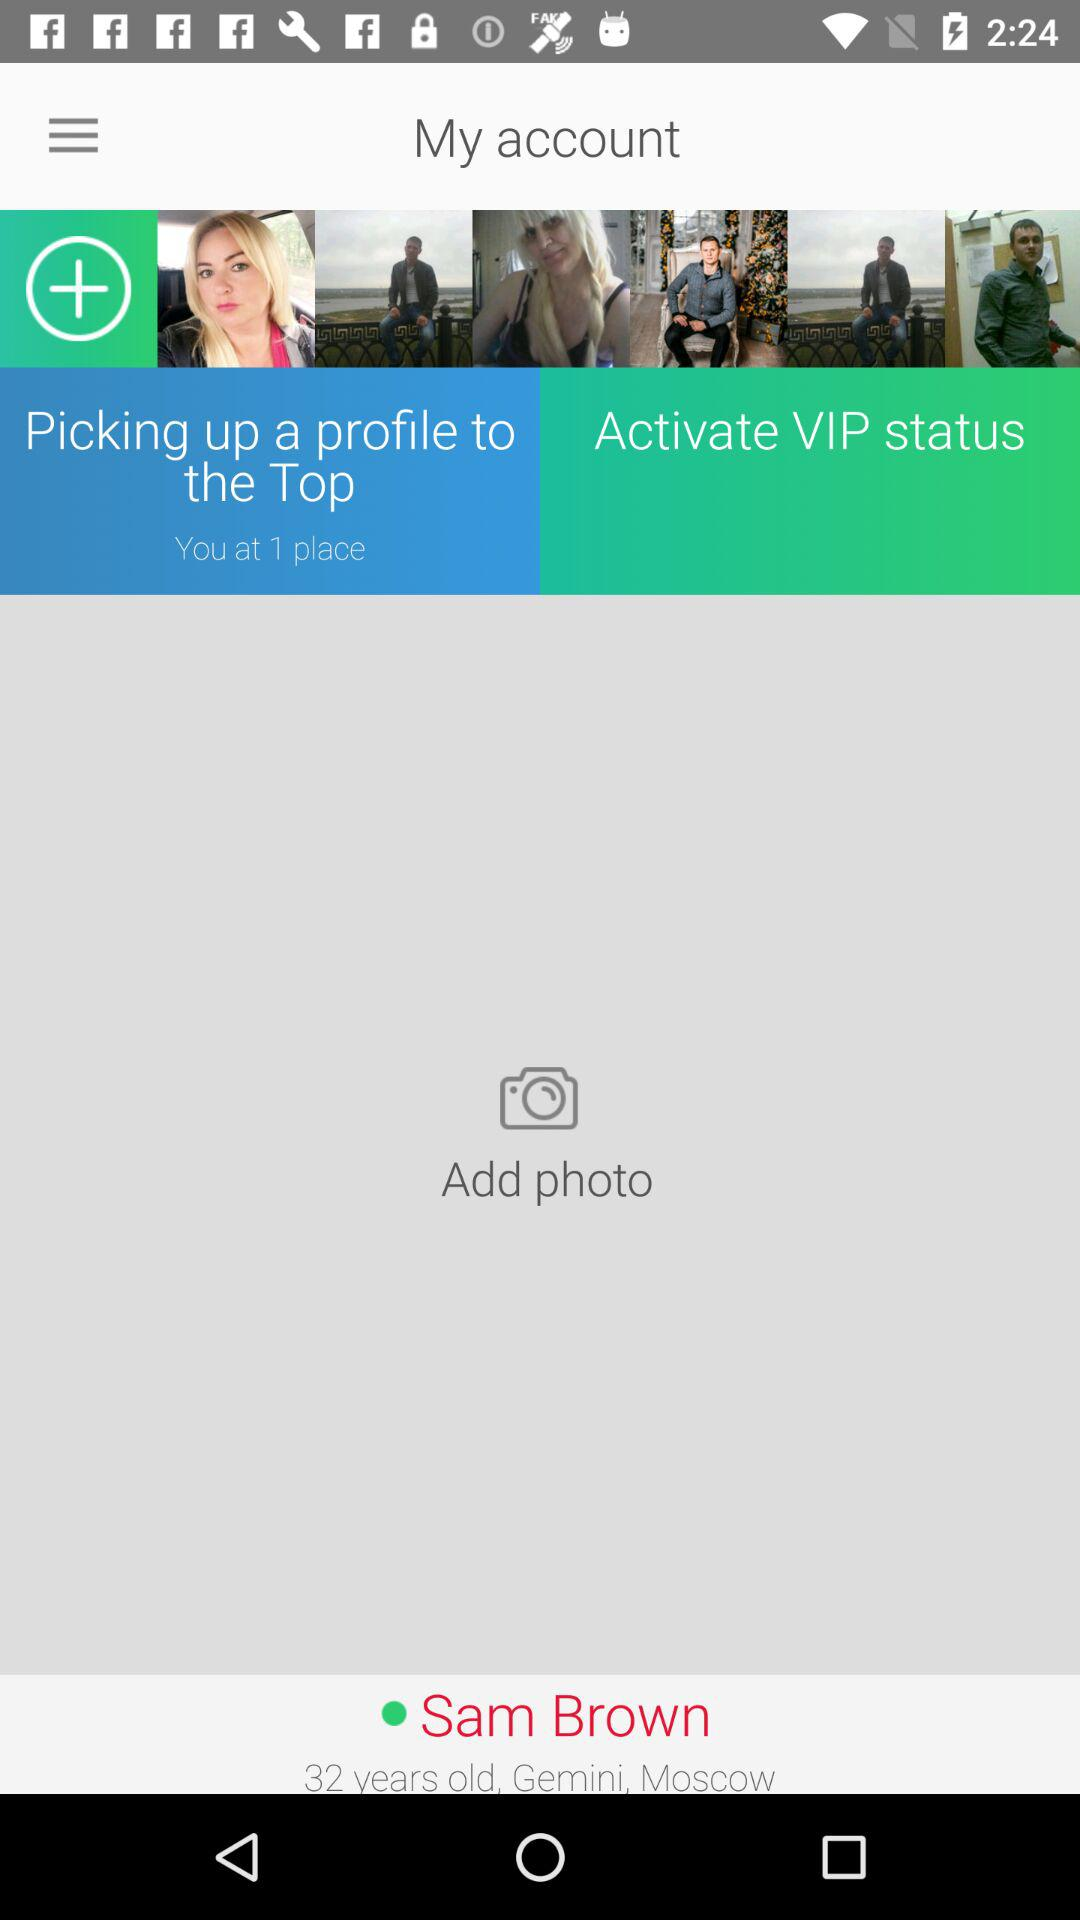How many more photos do I need to add to be in the top 10?
Answer the question using a single word or phrase. 9 